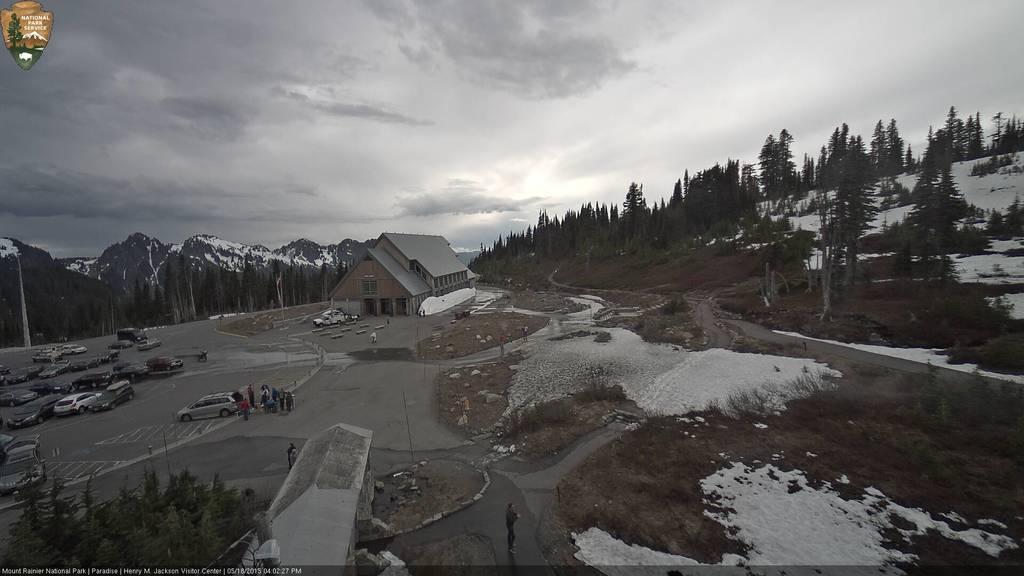Please provide a concise description of this image. In the picture we can see a surface on the hill with some part of road and some part of grass surface with snow on it and we can see a house building and near it we can see a vehicle and on the road surface we can see some vehicles are parked and behind the house we can see a part of the hill slope covered with trees, and snow and on another side we can see a hill covered with trees and behind it we can see mountains with some snow on it and in the background we can see the sky with clouds. 